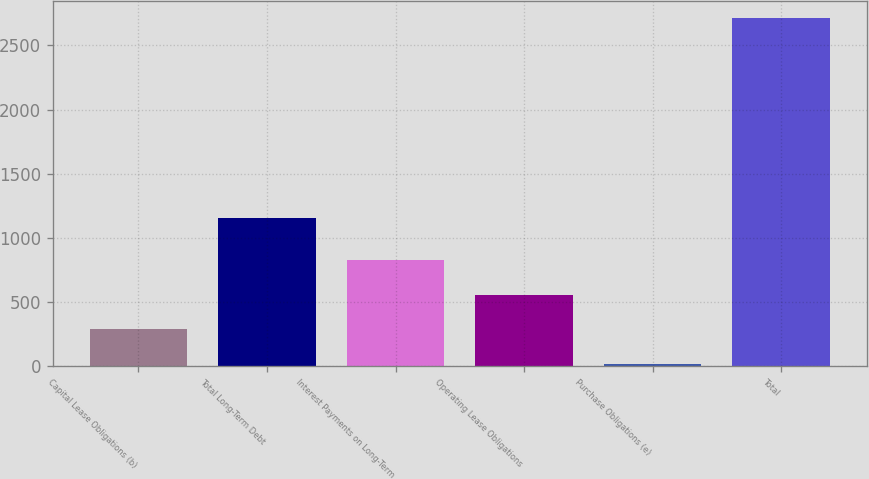<chart> <loc_0><loc_0><loc_500><loc_500><bar_chart><fcel>Capital Lease Obligations (b)<fcel>Total Long-Term Debt<fcel>Interest Payments on Long-Term<fcel>Operating Lease Obligations<fcel>Purchase Obligations (e)<fcel>Total<nl><fcel>285.03<fcel>1154.6<fcel>824.49<fcel>554.76<fcel>15.3<fcel>2712.6<nl></chart> 